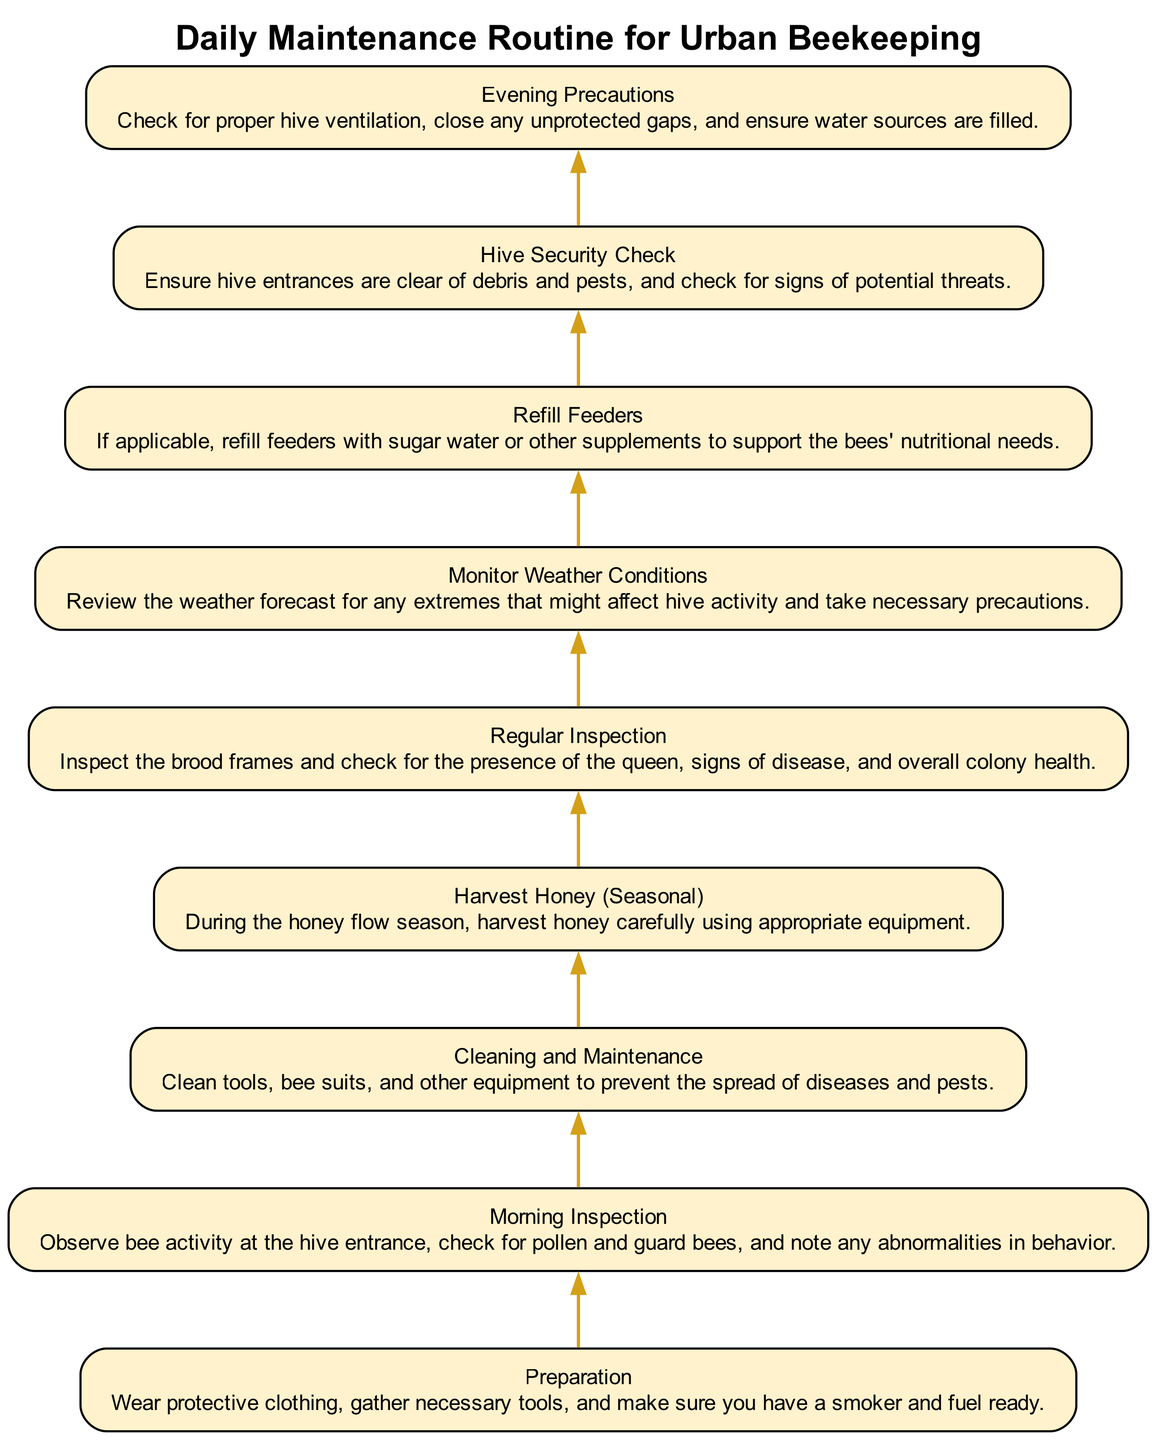What is at the top of the diagram? The top of the diagram lists "Evening Precautions," which is the final step in the daily maintenance routine.
Answer: Evening Precautions How many total elements are in the diagram? The diagram contains a total of nine elements, representing different steps in the maintenance routine.
Answer: Nine What is the second element from the top? The second element from the top is "Hive Security Check," which comes after "Evening Precautions."
Answer: Hive Security Check Which element indicates checking the weather? The element "Monitor Weather Conditions" indicates the importance of reviewing weather forecasts and their potential effects on hive activity.
Answer: Monitor Weather Conditions What comes before "Refill Feeders"? Before "Refill Feeders," the element "Regular Inspection" is listed, detailing the need to check the overall health of the bee colony.
Answer: Regular Inspection In which step do you observe bee activity? The step "Morning Inspection" is where one observes bee activity at the hive entrance.
Answer: Morning Inspection What is the purpose of the "Cleaning and Maintenance" step? The purpose of "Cleaning and Maintenance" involves cleaning tools and equipment to minimize the risk of disease and pest spread.
Answer: Prevent spread of diseases and pests What element provides a check for nectar season? The element "Harvest Honey (Seasonal)" mentions honey harvesting during the honey flow season, which relates to nectar availability.
Answer: Harvest Honey (Seasonal) Which step requires protective clothing? The step "Preparation" emphasizes the need to wear protective clothing before working with the hives.
Answer: Preparation 